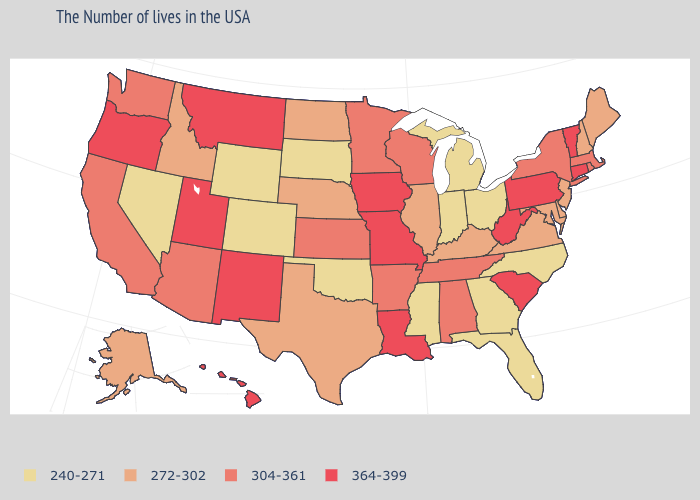Among the states that border New Hampshire , which have the highest value?
Be succinct. Vermont. What is the value of Montana?
Concise answer only. 364-399. Among the states that border North Dakota , which have the lowest value?
Answer briefly. South Dakota. What is the value of Nebraska?
Short answer required. 272-302. What is the value of Arizona?
Give a very brief answer. 304-361. Among the states that border Pennsylvania , which have the highest value?
Concise answer only. West Virginia. Name the states that have a value in the range 272-302?
Give a very brief answer. Maine, New Hampshire, New Jersey, Delaware, Maryland, Virginia, Kentucky, Illinois, Nebraska, Texas, North Dakota, Idaho, Alaska. What is the highest value in states that border Wyoming?
Concise answer only. 364-399. What is the value of Idaho?
Answer briefly. 272-302. Among the states that border Minnesota , does South Dakota have the highest value?
Write a very short answer. No. What is the highest value in the South ?
Short answer required. 364-399. Among the states that border Maryland , which have the highest value?
Answer briefly. Pennsylvania, West Virginia. What is the highest value in the South ?
Give a very brief answer. 364-399. Name the states that have a value in the range 304-361?
Concise answer only. Massachusetts, Rhode Island, New York, Alabama, Tennessee, Wisconsin, Arkansas, Minnesota, Kansas, Arizona, California, Washington. Name the states that have a value in the range 272-302?
Write a very short answer. Maine, New Hampshire, New Jersey, Delaware, Maryland, Virginia, Kentucky, Illinois, Nebraska, Texas, North Dakota, Idaho, Alaska. 